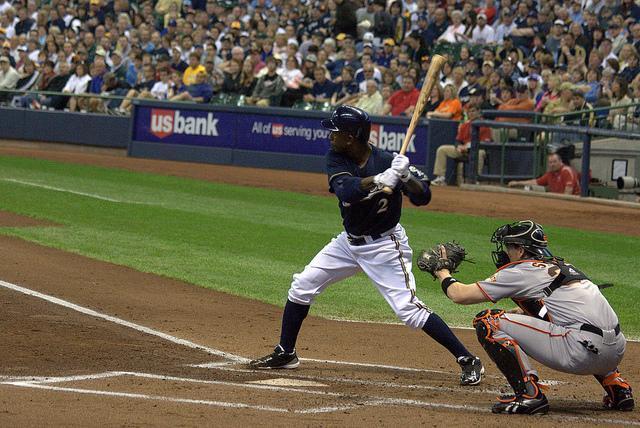How many people are wearing protective face masks?
Give a very brief answer. 1. How many people are visible?
Give a very brief answer. 3. How many polo bears are in the image?
Give a very brief answer. 0. 